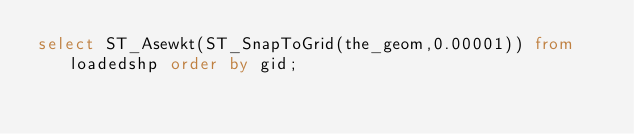Convert code to text. <code><loc_0><loc_0><loc_500><loc_500><_SQL_>select ST_Asewkt(ST_SnapToGrid(the_geom,0.00001)) from loadedshp order by gid;

</code> 